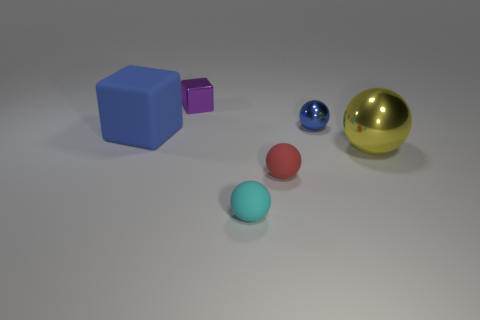Subtract all big metallic balls. How many balls are left? 3 Add 1 small cubes. How many objects exist? 7 Subtract 1 cubes. How many cubes are left? 1 Subtract all red balls. How many balls are left? 3 Subtract all metallic cubes. Subtract all metallic blocks. How many objects are left? 4 Add 3 tiny red things. How many tiny red things are left? 4 Add 6 blue matte blocks. How many blue matte blocks exist? 7 Subtract 0 gray cubes. How many objects are left? 6 Subtract all cubes. How many objects are left? 4 Subtract all red spheres. Subtract all blue blocks. How many spheres are left? 3 